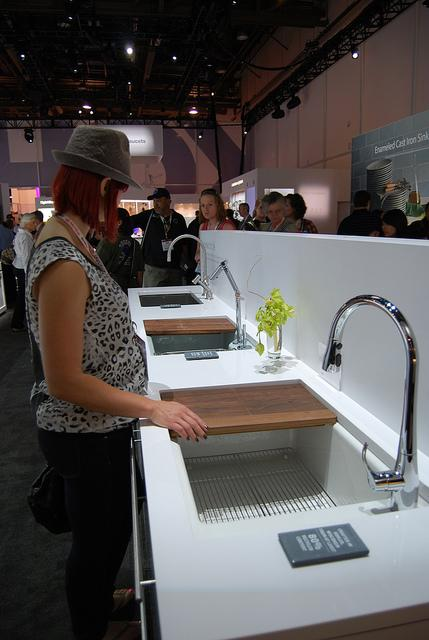If this person wanted to wash their hands where would they have to go? Please explain your reasoning. bathroom. This is a display and unlikely connected to water. 